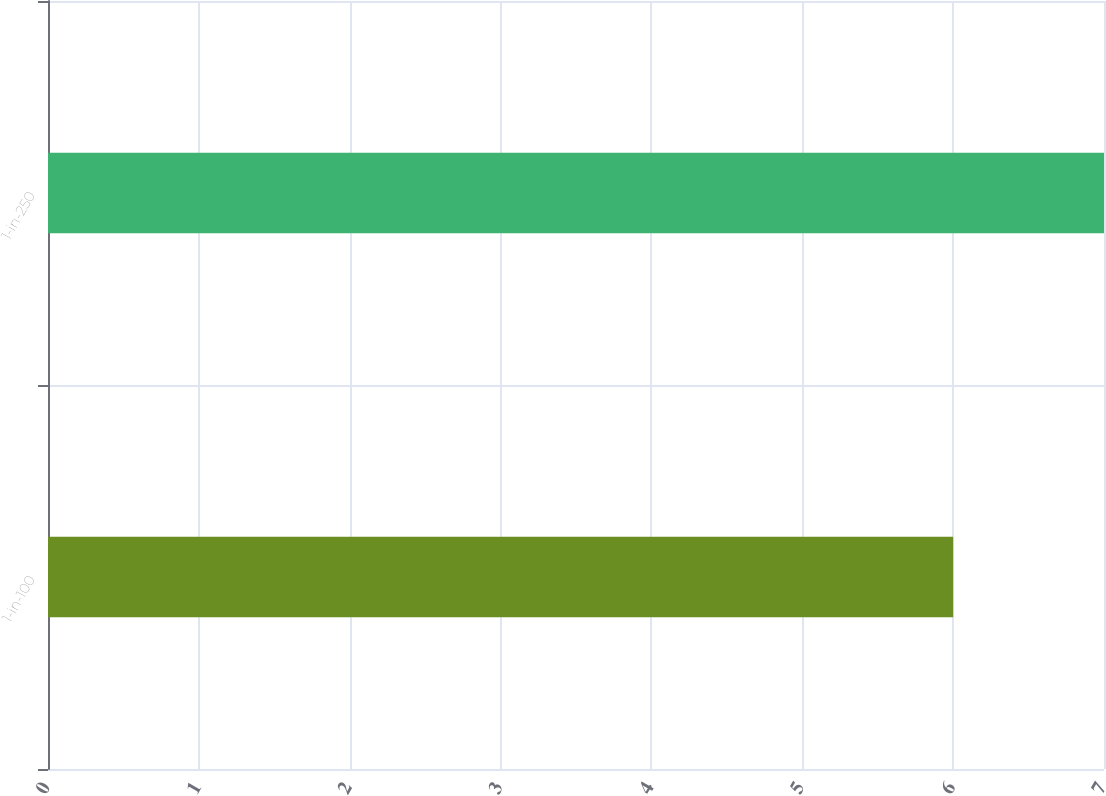<chart> <loc_0><loc_0><loc_500><loc_500><bar_chart><fcel>1-in-100<fcel>1-in-250<nl><fcel>6<fcel>7<nl></chart> 